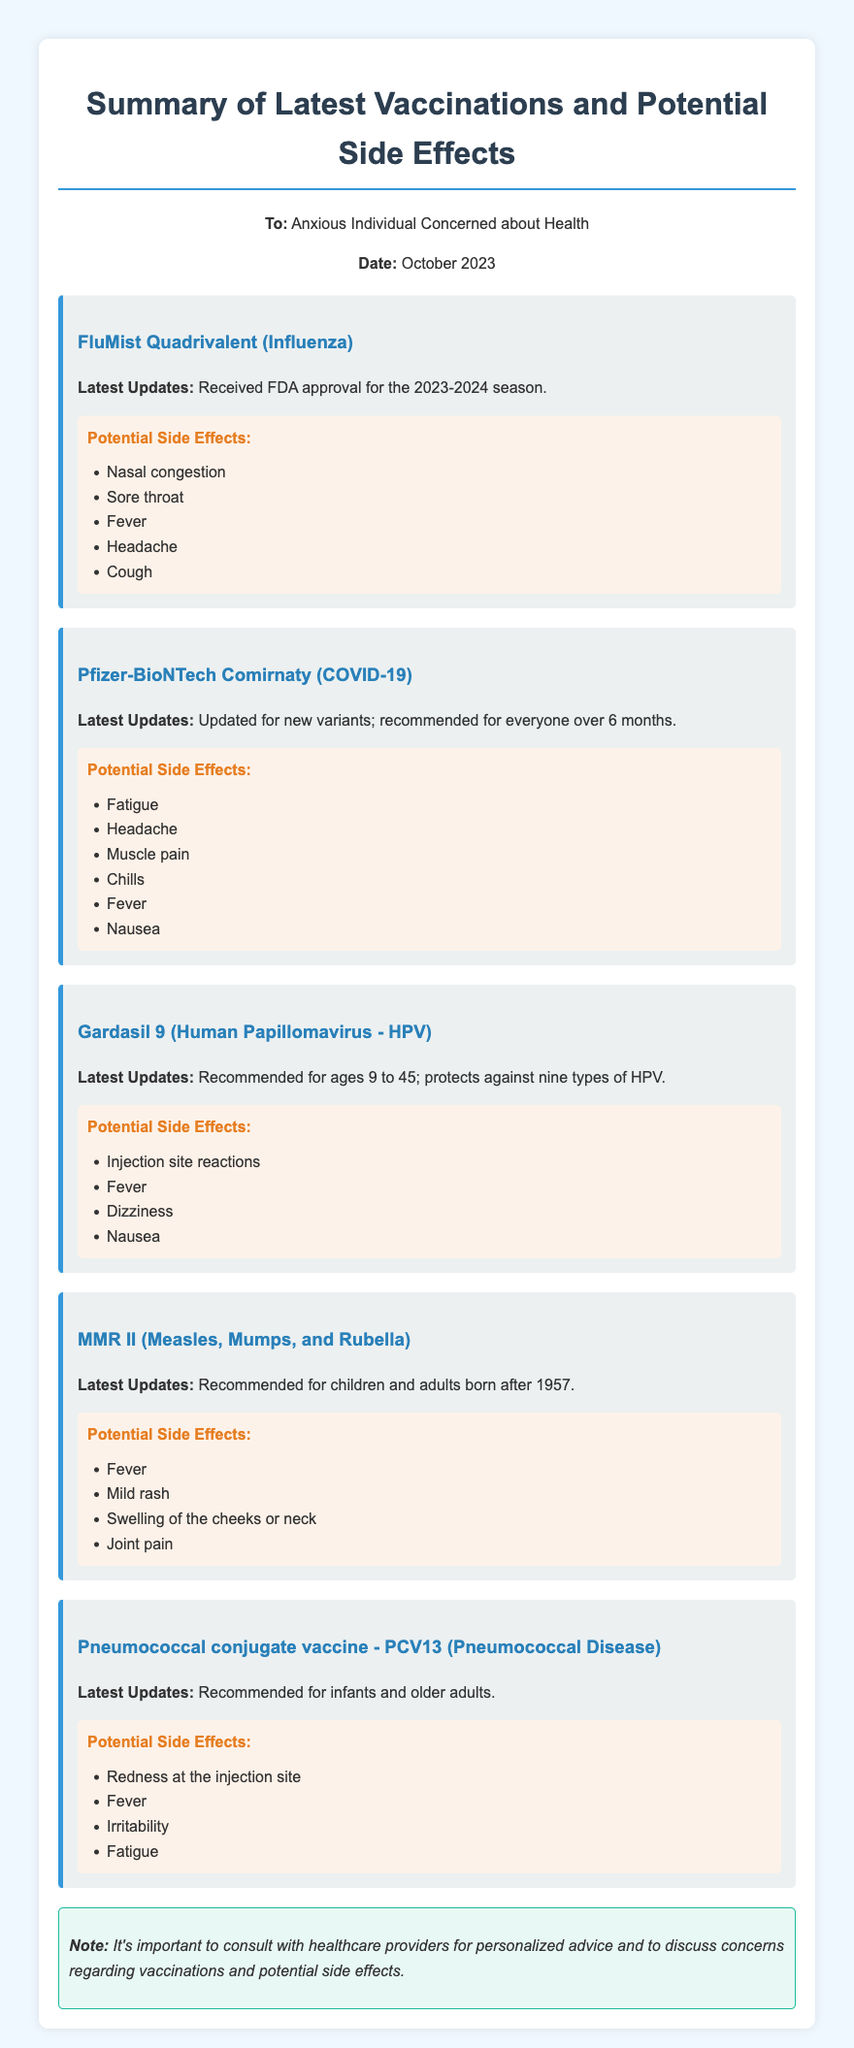What is the title of the memo? The title of the memo is found at the top section of the document.
Answer: Summary of Latest Vaccinations and Potential Side Effects What is the date of the memo? The date is provided in the header section of the memo.
Answer: October 2023 Which vaccine is updated for new variants? The document lists the vaccines along with their latest updates, specifying which vaccines have new updates.
Answer: Pfizer-BioNTech Comirnaty What age group is Gardasil 9 recommended for? The memo states the recommended age range for the Gardasil 9 vaccine.
Answer: 9 to 45 List one potential side effect of the FluMist Quadrivalent vaccine. The side effects are outlined in bullet points under each vaccine, identifying potential reactions.
Answer: Nasal congestion How many types of HPV does Gardasil 9 protect against? The number of HPV types protected by Gardasil 9 is specifically mentioned in the document.
Answer: Nine What is the potential side effect that appears in all vaccine cards? By examining each vaccine's side effects listed, a commonality can be deduced.
Answer: Fever Who is the memo addressed to? The recipient of the memo is clearly stated in the header.
Answer: Anxious Individual Concerned about Health 